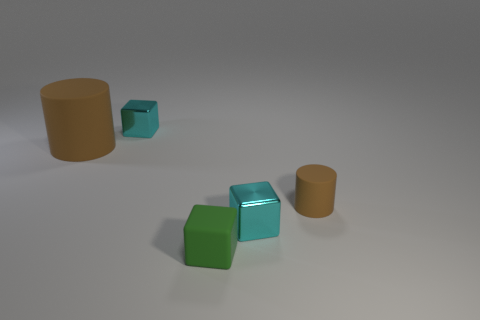Add 3 big blue matte cylinders. How many objects exist? 8 Subtract all cylinders. How many objects are left? 3 Add 3 small brown rubber balls. How many small brown rubber balls exist? 3 Subtract 0 yellow blocks. How many objects are left? 5 Subtract all big things. Subtract all small things. How many objects are left? 0 Add 5 tiny cyan shiny things. How many tiny cyan shiny things are left? 7 